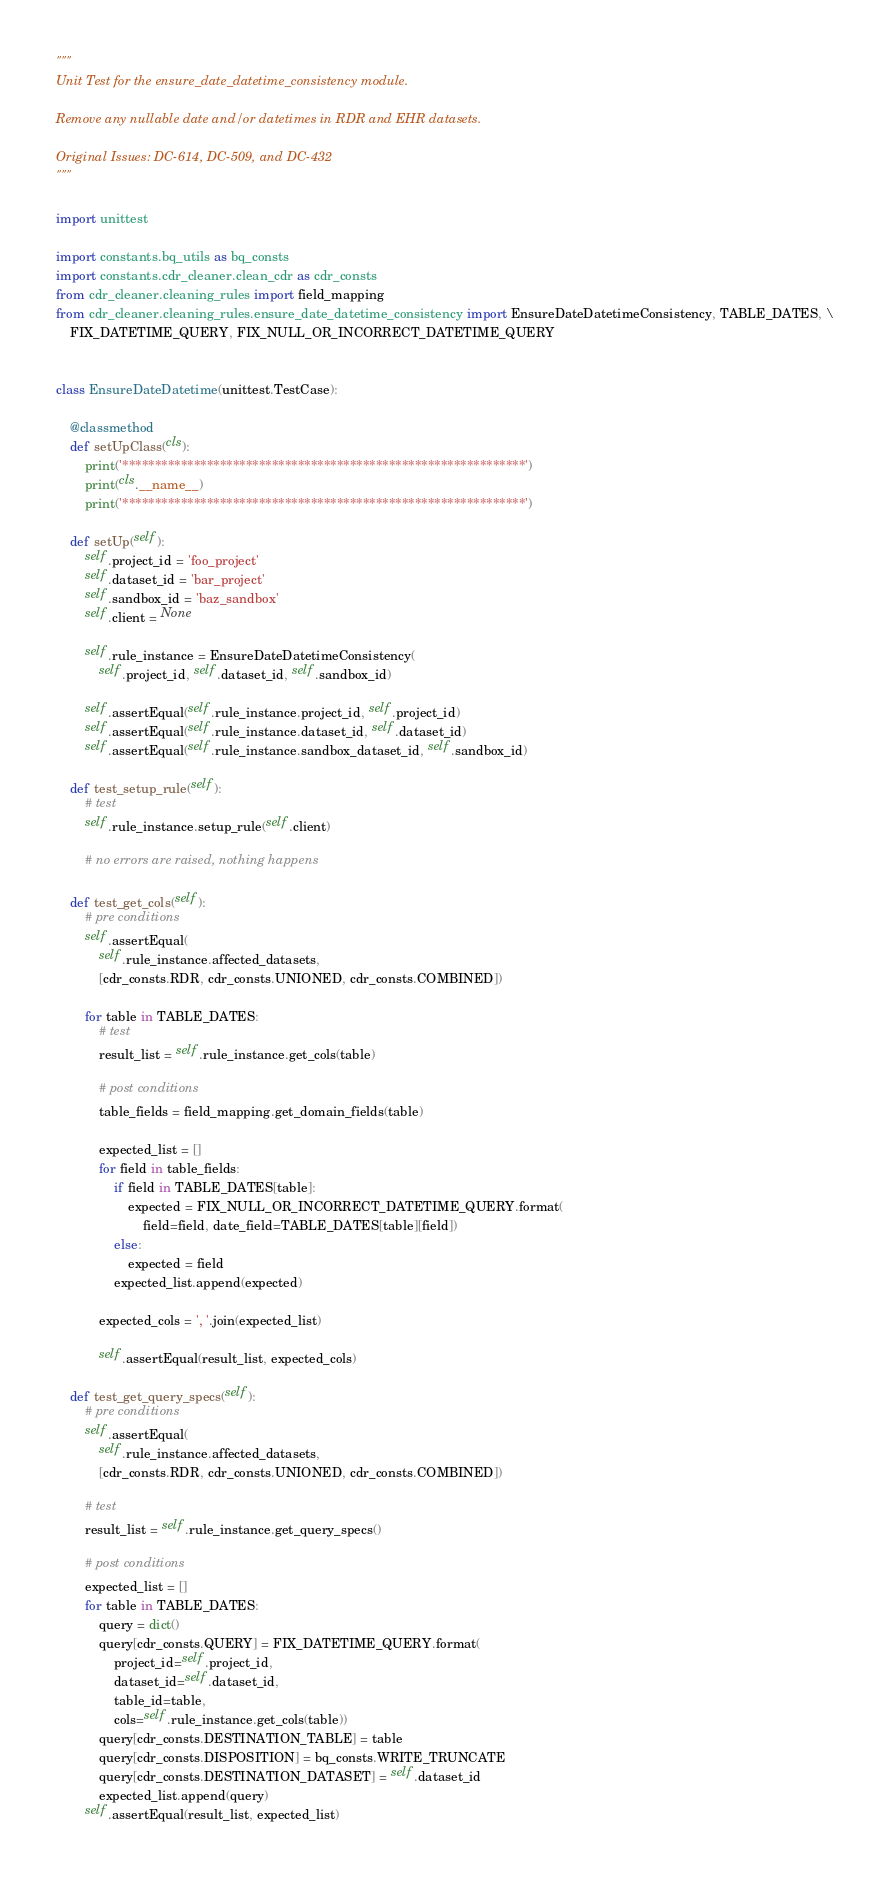Convert code to text. <code><loc_0><loc_0><loc_500><loc_500><_Python_>"""
Unit Test for the ensure_date_datetime_consistency module.

Remove any nullable date and/or datetimes in RDR and EHR datasets.

Original Issues: DC-614, DC-509, and DC-432
"""

import unittest

import constants.bq_utils as bq_consts
import constants.cdr_cleaner.clean_cdr as cdr_consts
from cdr_cleaner.cleaning_rules import field_mapping
from cdr_cleaner.cleaning_rules.ensure_date_datetime_consistency import EnsureDateDatetimeConsistency, TABLE_DATES, \
    FIX_DATETIME_QUERY, FIX_NULL_OR_INCORRECT_DATETIME_QUERY


class EnsureDateDatetime(unittest.TestCase):

    @classmethod
    def setUpClass(cls):
        print('**************************************************************')
        print(cls.__name__)
        print('**************************************************************')

    def setUp(self):
        self.project_id = 'foo_project'
        self.dataset_id = 'bar_project'
        self.sandbox_id = 'baz_sandbox'
        self.client = None

        self.rule_instance = EnsureDateDatetimeConsistency(
            self.project_id, self.dataset_id, self.sandbox_id)

        self.assertEqual(self.rule_instance.project_id, self.project_id)
        self.assertEqual(self.rule_instance.dataset_id, self.dataset_id)
        self.assertEqual(self.rule_instance.sandbox_dataset_id, self.sandbox_id)

    def test_setup_rule(self):
        # test
        self.rule_instance.setup_rule(self.client)

        # no errors are raised, nothing happens

    def test_get_cols(self):
        # pre conditions
        self.assertEqual(
            self.rule_instance.affected_datasets,
            [cdr_consts.RDR, cdr_consts.UNIONED, cdr_consts.COMBINED])

        for table in TABLE_DATES:
            # test
            result_list = self.rule_instance.get_cols(table)

            # post conditions
            table_fields = field_mapping.get_domain_fields(table)

            expected_list = []
            for field in table_fields:
                if field in TABLE_DATES[table]:
                    expected = FIX_NULL_OR_INCORRECT_DATETIME_QUERY.format(
                        field=field, date_field=TABLE_DATES[table][field])
                else:
                    expected = field
                expected_list.append(expected)

            expected_cols = ', '.join(expected_list)

            self.assertEqual(result_list, expected_cols)

    def test_get_query_specs(self):
        # pre conditions
        self.assertEqual(
            self.rule_instance.affected_datasets,
            [cdr_consts.RDR, cdr_consts.UNIONED, cdr_consts.COMBINED])

        # test
        result_list = self.rule_instance.get_query_specs()

        # post conditions
        expected_list = []
        for table in TABLE_DATES:
            query = dict()
            query[cdr_consts.QUERY] = FIX_DATETIME_QUERY.format(
                project_id=self.project_id,
                dataset_id=self.dataset_id,
                table_id=table,
                cols=self.rule_instance.get_cols(table))
            query[cdr_consts.DESTINATION_TABLE] = table
            query[cdr_consts.DISPOSITION] = bq_consts.WRITE_TRUNCATE
            query[cdr_consts.DESTINATION_DATASET] = self.dataset_id
            expected_list.append(query)
        self.assertEqual(result_list, expected_list)
</code> 